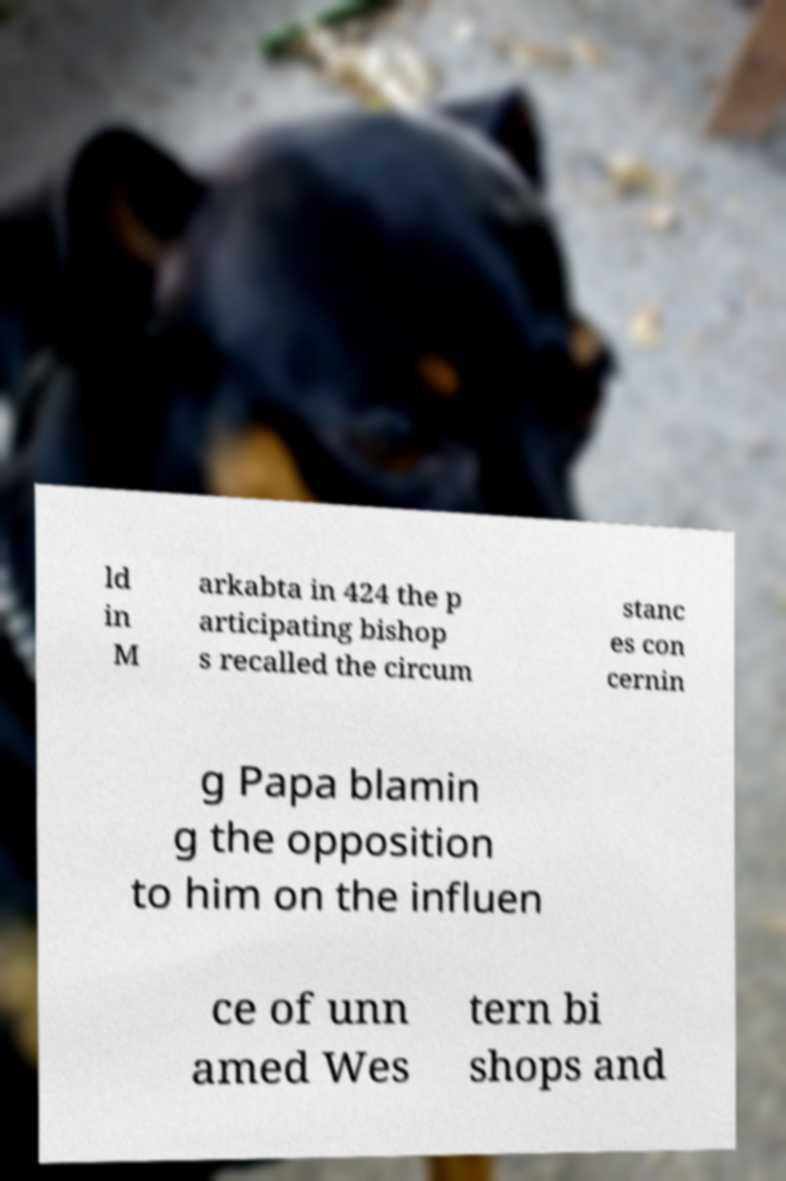Can you accurately transcribe the text from the provided image for me? ld in M arkabta in 424 the p articipating bishop s recalled the circum stanc es con cernin g Papa blamin g the opposition to him on the influen ce of unn amed Wes tern bi shops and 